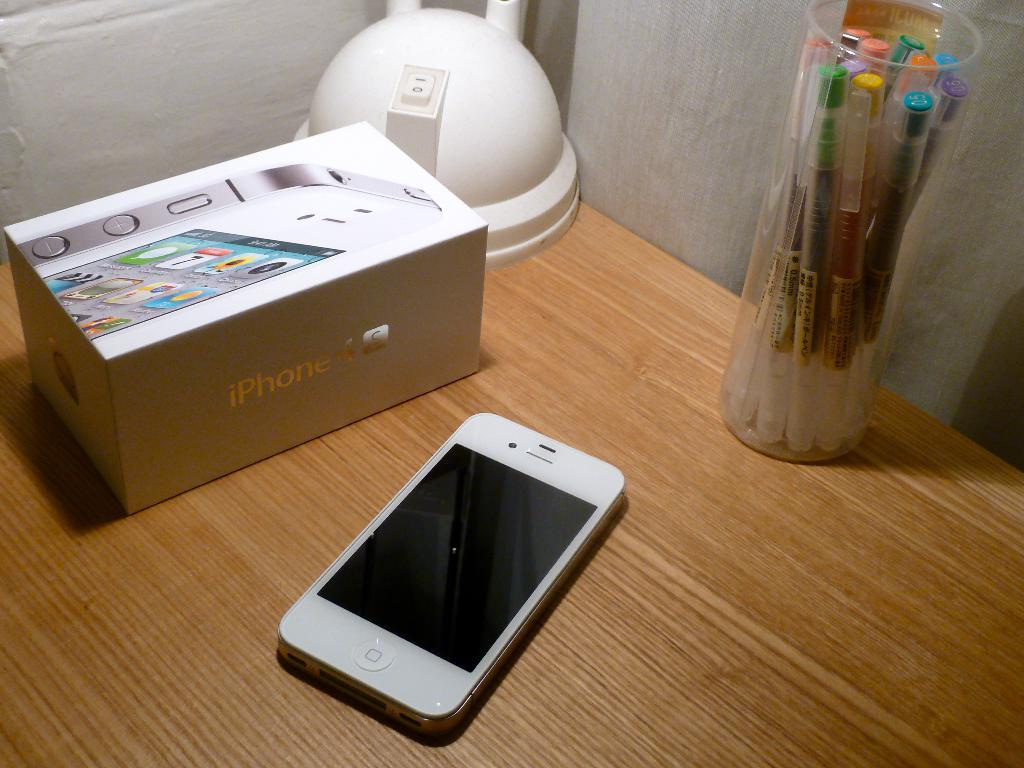<image>
Relay a brief, clear account of the picture shown. An iPhone 4 box sits on a wood desk next to the phone itself. 